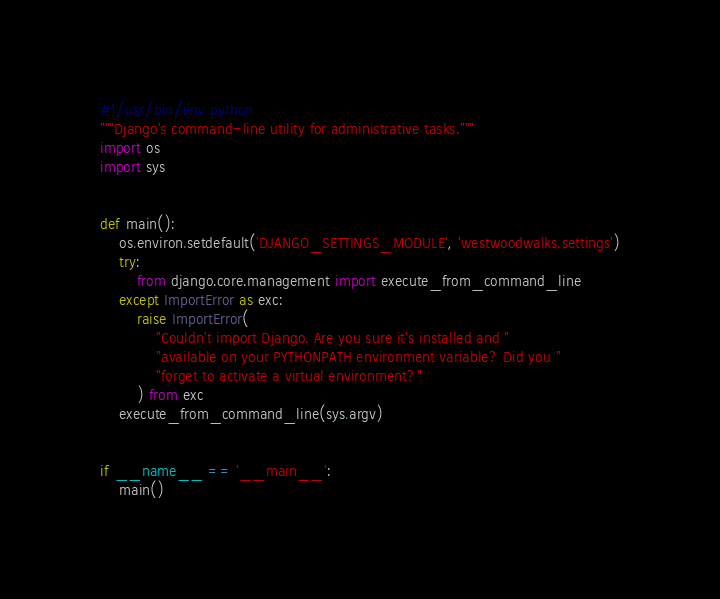Convert code to text. <code><loc_0><loc_0><loc_500><loc_500><_Python_>#!/usr/bin/env python
"""Django's command-line utility for administrative tasks."""
import os
import sys


def main():
    os.environ.setdefault('DJANGO_SETTINGS_MODULE', 'westwoodwalks.settings')
    try:
        from django.core.management import execute_from_command_line
    except ImportError as exc:
        raise ImportError(
            "Couldn't import Django. Are you sure it's installed and "
            "available on your PYTHONPATH environment variable? Did you "
            "forget to activate a virtual environment?"
        ) from exc
    execute_from_command_line(sys.argv)


if __name__ == '__main__':
    main()
</code> 